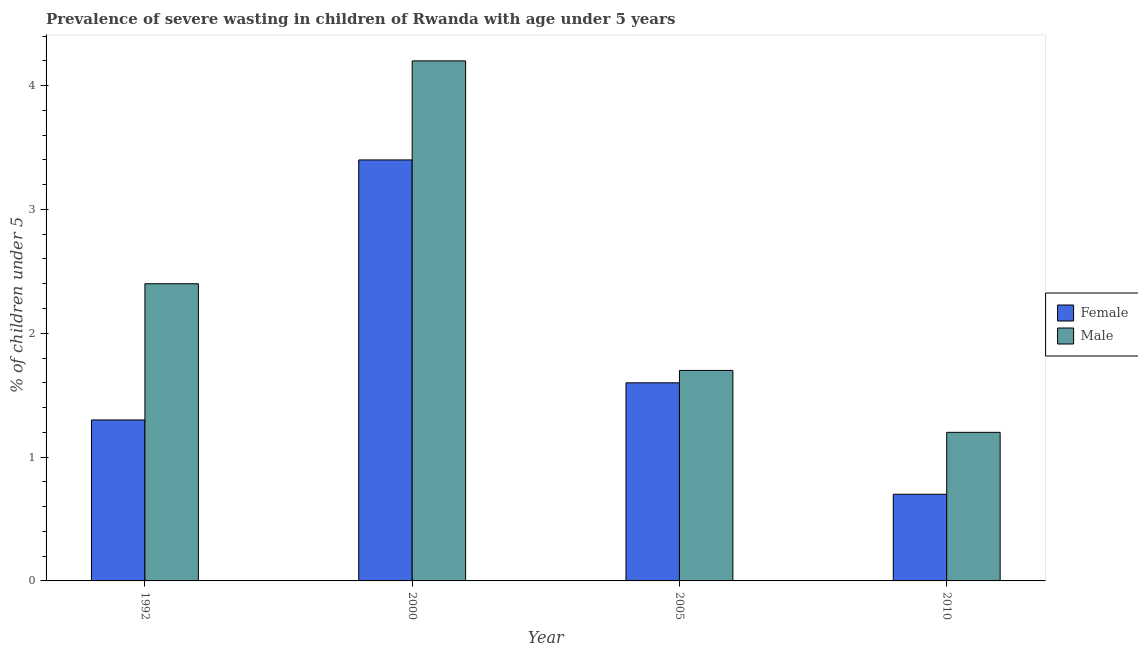How many groups of bars are there?
Offer a very short reply. 4. Are the number of bars on each tick of the X-axis equal?
Your answer should be very brief. Yes. How many bars are there on the 3rd tick from the right?
Offer a very short reply. 2. What is the label of the 1st group of bars from the left?
Give a very brief answer. 1992. In how many cases, is the number of bars for a given year not equal to the number of legend labels?
Keep it short and to the point. 0. What is the percentage of undernourished male children in 1992?
Your answer should be compact. 2.4. Across all years, what is the maximum percentage of undernourished female children?
Keep it short and to the point. 3.4. Across all years, what is the minimum percentage of undernourished male children?
Provide a short and direct response. 1.2. In which year was the percentage of undernourished male children minimum?
Offer a terse response. 2010. What is the total percentage of undernourished female children in the graph?
Provide a short and direct response. 7. What is the difference between the percentage of undernourished male children in 2000 and that in 2005?
Ensure brevity in your answer.  2.5. What is the difference between the percentage of undernourished female children in 2005 and the percentage of undernourished male children in 1992?
Your response must be concise. 0.3. What is the average percentage of undernourished male children per year?
Make the answer very short. 2.38. In the year 2010, what is the difference between the percentage of undernourished female children and percentage of undernourished male children?
Your response must be concise. 0. What is the ratio of the percentage of undernourished male children in 2000 to that in 2010?
Provide a succinct answer. 3.5. Is the percentage of undernourished female children in 1992 less than that in 2010?
Offer a terse response. No. What is the difference between the highest and the second highest percentage of undernourished male children?
Make the answer very short. 1.8. What is the difference between the highest and the lowest percentage of undernourished female children?
Your answer should be compact. 2.7. In how many years, is the percentage of undernourished male children greater than the average percentage of undernourished male children taken over all years?
Your answer should be very brief. 2. What does the 1st bar from the left in 2010 represents?
Keep it short and to the point. Female. How many bars are there?
Offer a very short reply. 8. Are all the bars in the graph horizontal?
Keep it short and to the point. No. What is the difference between two consecutive major ticks on the Y-axis?
Make the answer very short. 1. Are the values on the major ticks of Y-axis written in scientific E-notation?
Your answer should be compact. No. Does the graph contain grids?
Give a very brief answer. No. How are the legend labels stacked?
Give a very brief answer. Vertical. What is the title of the graph?
Keep it short and to the point. Prevalence of severe wasting in children of Rwanda with age under 5 years. Does "Age 65(female)" appear as one of the legend labels in the graph?
Your answer should be compact. No. What is the label or title of the X-axis?
Your answer should be compact. Year. What is the label or title of the Y-axis?
Provide a succinct answer.  % of children under 5. What is the  % of children under 5 in Female in 1992?
Keep it short and to the point. 1.3. What is the  % of children under 5 of Male in 1992?
Give a very brief answer. 2.4. What is the  % of children under 5 of Female in 2000?
Make the answer very short. 3.4. What is the  % of children under 5 in Male in 2000?
Offer a terse response. 4.2. What is the  % of children under 5 of Female in 2005?
Give a very brief answer. 1.6. What is the  % of children under 5 in Male in 2005?
Your answer should be compact. 1.7. What is the  % of children under 5 of Female in 2010?
Offer a very short reply. 0.7. What is the  % of children under 5 in Male in 2010?
Ensure brevity in your answer.  1.2. Across all years, what is the maximum  % of children under 5 in Female?
Your answer should be compact. 3.4. Across all years, what is the maximum  % of children under 5 in Male?
Give a very brief answer. 4.2. Across all years, what is the minimum  % of children under 5 in Female?
Make the answer very short. 0.7. Across all years, what is the minimum  % of children under 5 of Male?
Offer a very short reply. 1.2. What is the total  % of children under 5 in Male in the graph?
Your response must be concise. 9.5. What is the difference between the  % of children under 5 in Female in 1992 and that in 2000?
Give a very brief answer. -2.1. What is the difference between the  % of children under 5 of Female in 1992 and that in 2010?
Your answer should be compact. 0.6. What is the difference between the  % of children under 5 of Male in 1992 and that in 2010?
Ensure brevity in your answer.  1.2. What is the difference between the  % of children under 5 of Male in 2000 and that in 2005?
Your answer should be compact. 2.5. What is the difference between the  % of children under 5 of Male in 2005 and that in 2010?
Ensure brevity in your answer.  0.5. What is the difference between the  % of children under 5 in Female in 1992 and the  % of children under 5 in Male in 2000?
Ensure brevity in your answer.  -2.9. What is the difference between the  % of children under 5 in Female in 1992 and the  % of children under 5 in Male in 2010?
Your answer should be very brief. 0.1. What is the difference between the  % of children under 5 in Female in 2000 and the  % of children under 5 in Male in 2010?
Provide a short and direct response. 2.2. What is the average  % of children under 5 in Female per year?
Offer a very short reply. 1.75. What is the average  % of children under 5 of Male per year?
Offer a very short reply. 2.38. In the year 1992, what is the difference between the  % of children under 5 in Female and  % of children under 5 in Male?
Provide a succinct answer. -1.1. In the year 2000, what is the difference between the  % of children under 5 of Female and  % of children under 5 of Male?
Make the answer very short. -0.8. What is the ratio of the  % of children under 5 of Female in 1992 to that in 2000?
Keep it short and to the point. 0.38. What is the ratio of the  % of children under 5 in Male in 1992 to that in 2000?
Provide a short and direct response. 0.57. What is the ratio of the  % of children under 5 of Female in 1992 to that in 2005?
Make the answer very short. 0.81. What is the ratio of the  % of children under 5 of Male in 1992 to that in 2005?
Provide a succinct answer. 1.41. What is the ratio of the  % of children under 5 of Female in 1992 to that in 2010?
Provide a short and direct response. 1.86. What is the ratio of the  % of children under 5 of Male in 1992 to that in 2010?
Keep it short and to the point. 2. What is the ratio of the  % of children under 5 in Female in 2000 to that in 2005?
Provide a succinct answer. 2.12. What is the ratio of the  % of children under 5 in Male in 2000 to that in 2005?
Provide a succinct answer. 2.47. What is the ratio of the  % of children under 5 of Female in 2000 to that in 2010?
Your response must be concise. 4.86. What is the ratio of the  % of children under 5 in Male in 2000 to that in 2010?
Make the answer very short. 3.5. What is the ratio of the  % of children under 5 of Female in 2005 to that in 2010?
Your answer should be very brief. 2.29. What is the ratio of the  % of children under 5 of Male in 2005 to that in 2010?
Offer a very short reply. 1.42. What is the difference between the highest and the second highest  % of children under 5 in Female?
Make the answer very short. 1.8. What is the difference between the highest and the second highest  % of children under 5 of Male?
Make the answer very short. 1.8. 